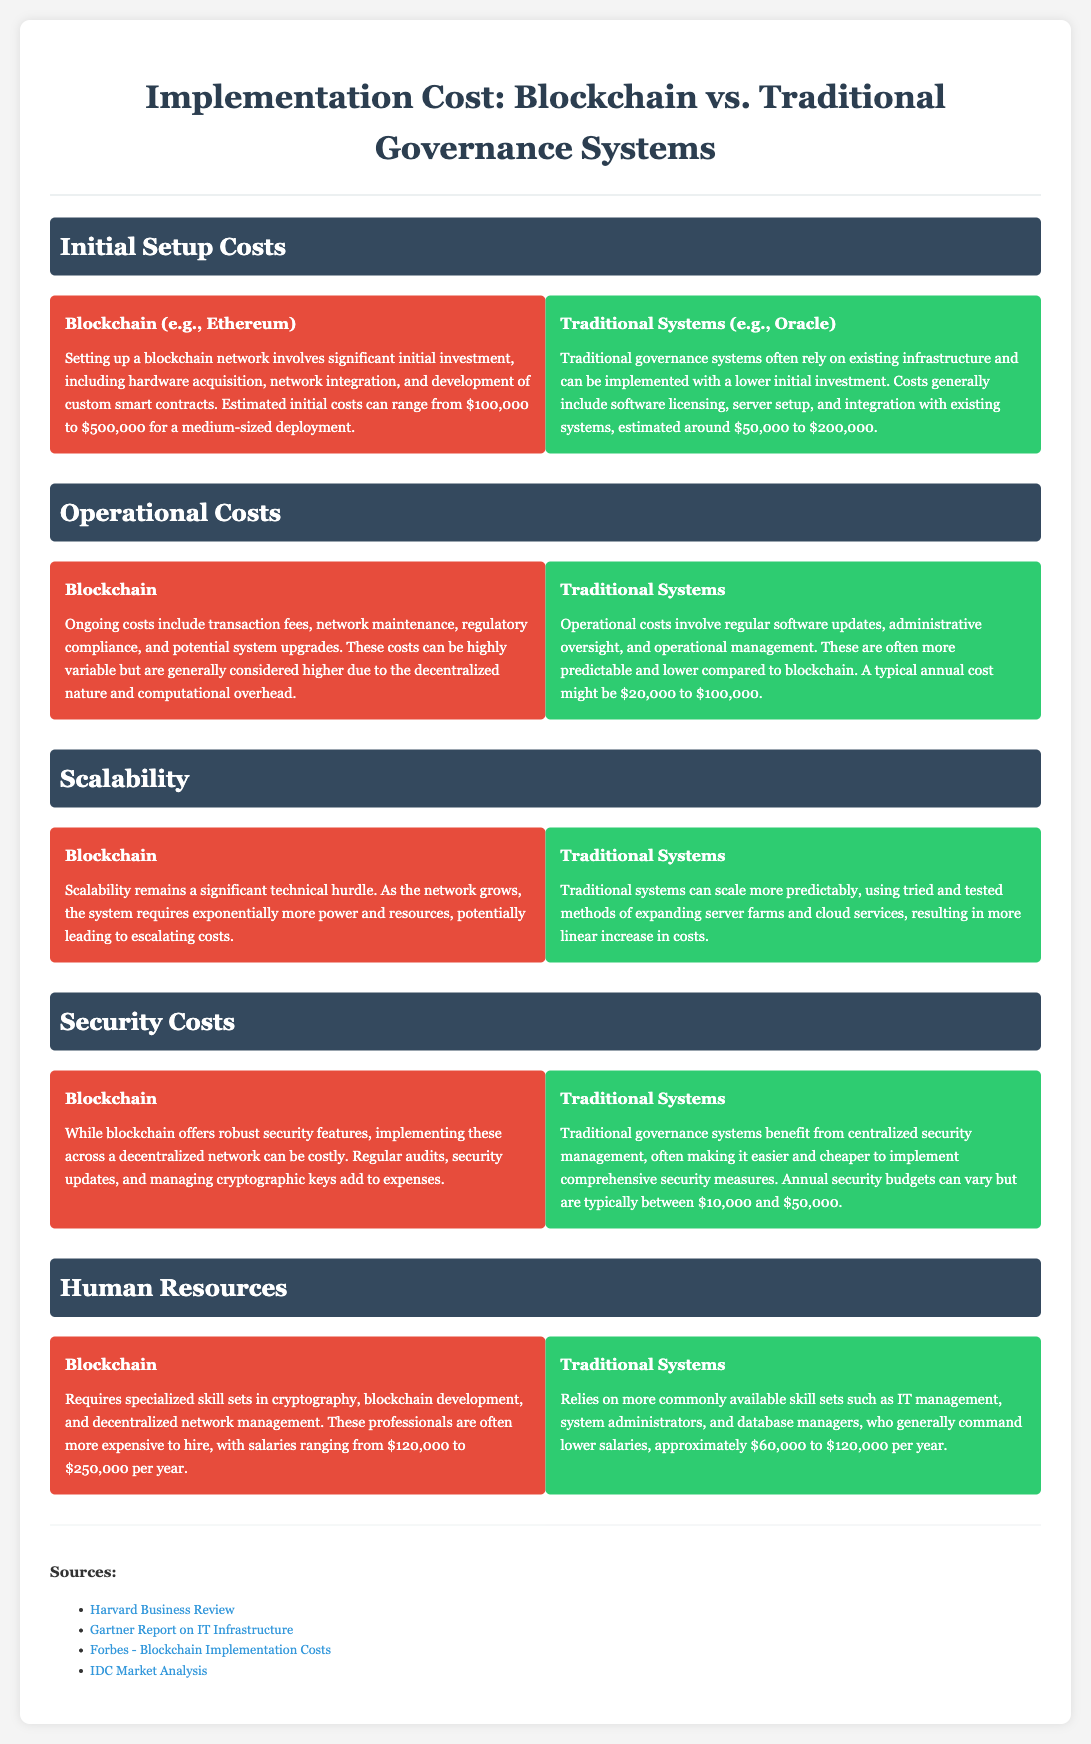What is the estimated initial cost range for blockchain implementation? The cost range for a medium-sized blockchain deployment is stated to be $100,000 to $500,000.
Answer: $100,000 to $500,000 What is the estimated initial cost range for traditional governance systems? Traditional governance systems can be implemented with a cost estimated around $50,000 to $200,000.
Answer: $50,000 to $200,000 What is a significant factor impacting blockchain operational costs? Ongoing costs for blockchain are considered higher due to the decentralized nature and computational overhead.
Answer: Decentralized nature and computational overhead What is the typical annual cost for traditional governance operational management? A typical annual cost for traditional governance systems might be $20,000 to $100,000.
Answer: $20,000 to $100,000 What salaries can blockchain professionals expect? Blockchain professionals' salaries range from $120,000 to $250,000 per year.
Answer: $120,000 to $250,000 per year What type of management benefits does a traditional system use for security? Traditional governance systems benefit from centralized security management.
Answer: Centralized security management Which system has more unpredictable scalability costs? Blockchain scalability costs are considered less predictable compared to traditional systems.
Answer: Blockchain What is a typical range for the annual security budget of traditional systems? The typical annual security budget for traditional systems varies but is typically between $10,000 and $50,000.
Answer: $10,000 to $50,000 What is required regarding skill sets for blockchain implementation? Blockchain implementation requires specialized skill sets in cryptography, blockchain development, and decentralized network management.
Answer: Specialized skill sets 